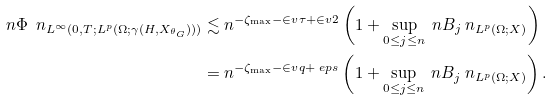<formula> <loc_0><loc_0><loc_500><loc_500>\ n \Phi \ n _ { L ^ { \infty } ( 0 , T ; L ^ { p } ( \Omega ; \gamma ( H , X _ { \theta _ { G } } ) ) ) } & \lesssim n ^ { - \zeta _ { \max } - \in v { \tau } + \in v { 2 } } \left ( 1 + \sup _ { 0 \leq j \leq n } \ n B _ { j } \ n _ { L ^ { p } ( \Omega ; X ) } \right ) \\ & = n ^ { - \zeta _ { \max } - \in v { q } + \ e p s } \left ( 1 + \sup _ { 0 \leq j \leq n } \ n B _ { j } \ n _ { L ^ { p } ( \Omega ; X ) } \right ) .</formula> 